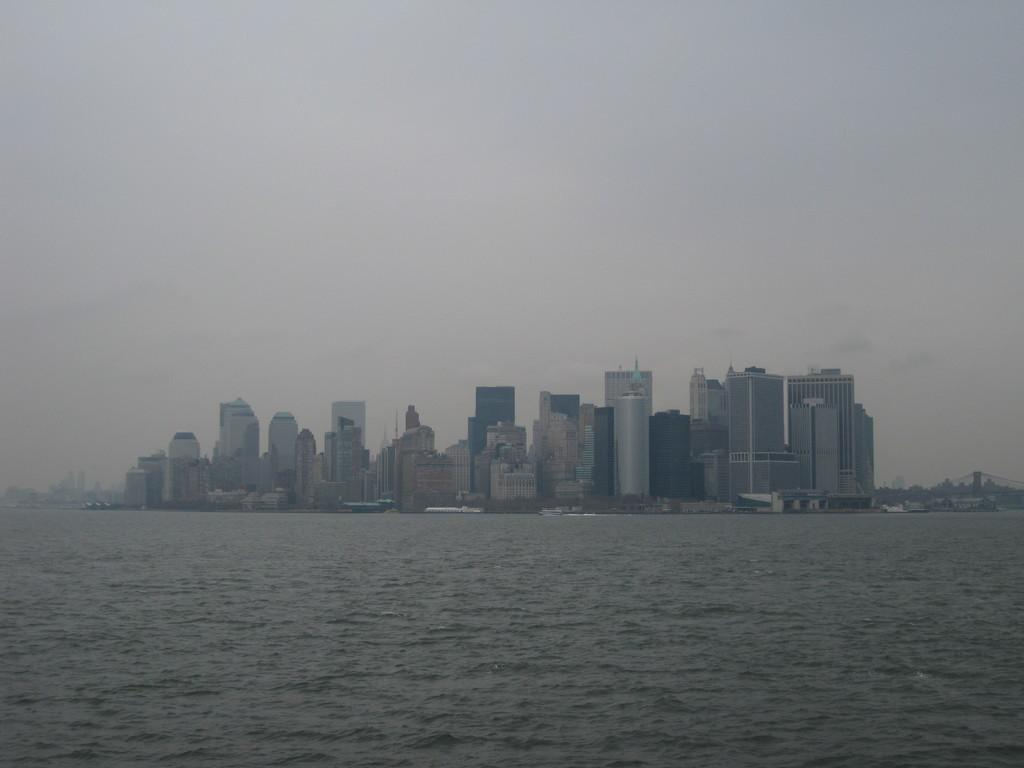What is the primary element visible in the image? There is water in the image. What structures can be seen in the image? There are buildings in the middle of the image. How many rabbits are sitting on the seat in the image? There are no rabbits or seats present in the image. 